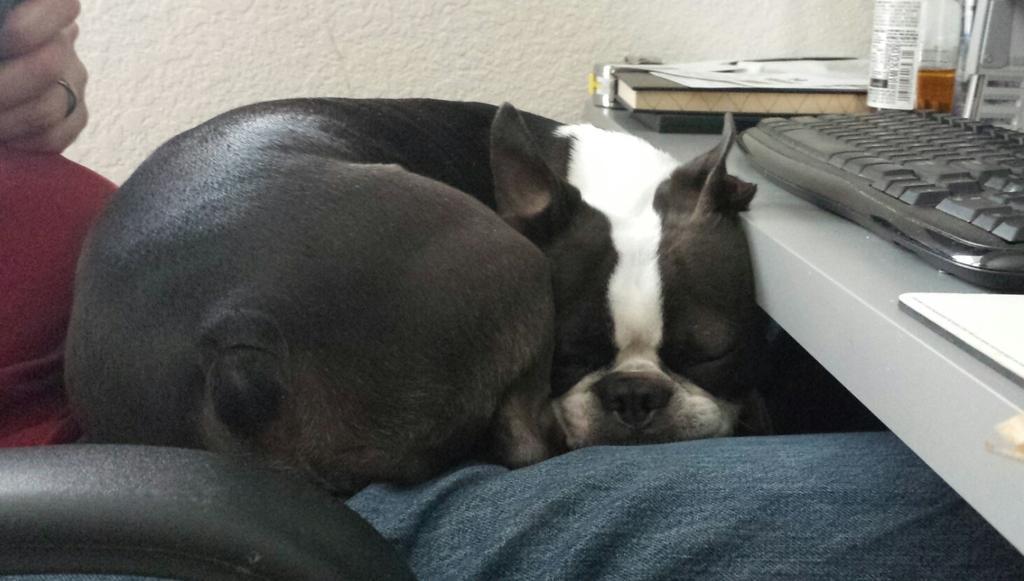Can you describe this image briefly? In this image we can see a dog sleeping on a person. On the right side, we can see few objects on a table. Behind the dog we can see a wall. At the bottom we can see a black object. 